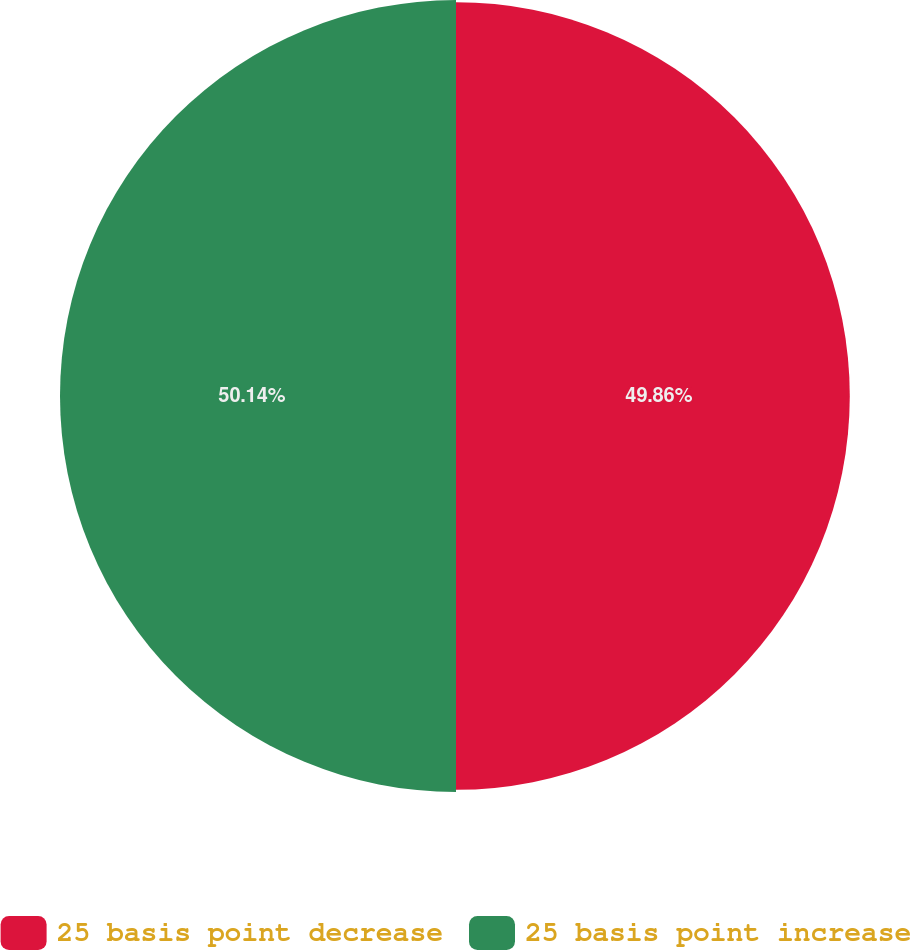Convert chart to OTSL. <chart><loc_0><loc_0><loc_500><loc_500><pie_chart><fcel>25 basis point decrease<fcel>25 basis point increase<nl><fcel>49.86%<fcel>50.14%<nl></chart> 